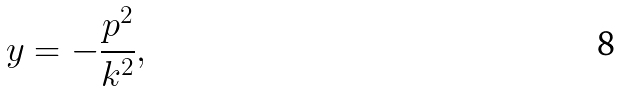Convert formula to latex. <formula><loc_0><loc_0><loc_500><loc_500>y = - \frac { p ^ { 2 } } { k ^ { 2 } } ,</formula> 